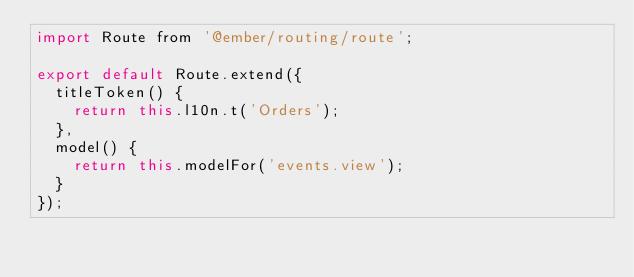Convert code to text. <code><loc_0><loc_0><loc_500><loc_500><_JavaScript_>import Route from '@ember/routing/route';

export default Route.extend({
  titleToken() {
    return this.l10n.t('Orders');
  },
  model() {
    return this.modelFor('events.view');
  }
});
</code> 